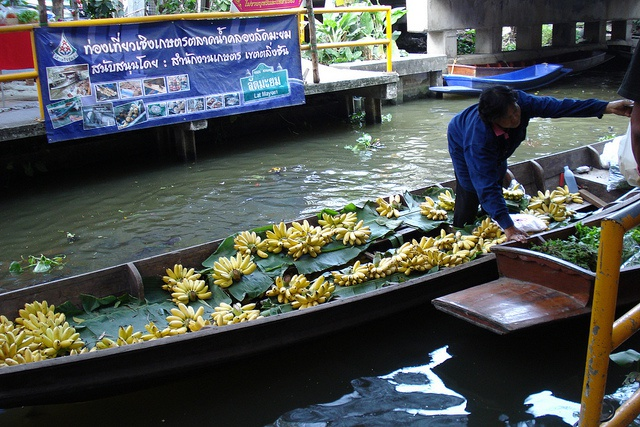Describe the objects in this image and their specific colors. I can see boat in darkgreen, black, gray, ivory, and olive tones, banana in darkgreen, olive, black, and ivory tones, boat in darkgreen, black, gray, and maroon tones, people in darkgreen, black, navy, gray, and blue tones, and boat in darkgreen, black, blue, lightblue, and navy tones in this image. 